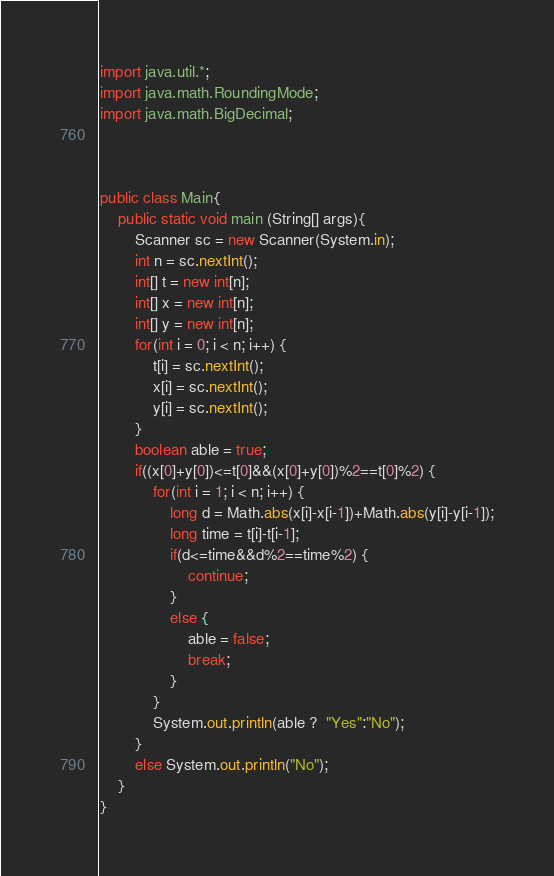<code> <loc_0><loc_0><loc_500><loc_500><_Java_>import java.util.*;
import java.math.RoundingMode;
import java.math.BigDecimal;
 
 
 
public class Main{
	public static void main (String[] args){
		Scanner sc = new Scanner(System.in);
		int n = sc.nextInt();
		int[] t = new int[n];
		int[] x = new int[n];
		int[] y = new int[n];
		for(int i = 0; i < n; i++) {
			t[i] = sc.nextInt();
			x[i] = sc.nextInt();
			y[i] = sc.nextInt();
		}
		boolean able = true;
		if((x[0]+y[0])<=t[0]&&(x[0]+y[0])%2==t[0]%2) {
			for(int i = 1; i < n; i++) {
				long d = Math.abs(x[i]-x[i-1])+Math.abs(y[i]-y[i-1]);
				long time = t[i]-t[i-1];
				if(d<=time&&d%2==time%2) {
					continue;
				}
				else {
					able = false;
					break;
				}
			}
			System.out.println(able ?  "Yes":"No");
		}
		else System.out.println("No");
	}
}</code> 